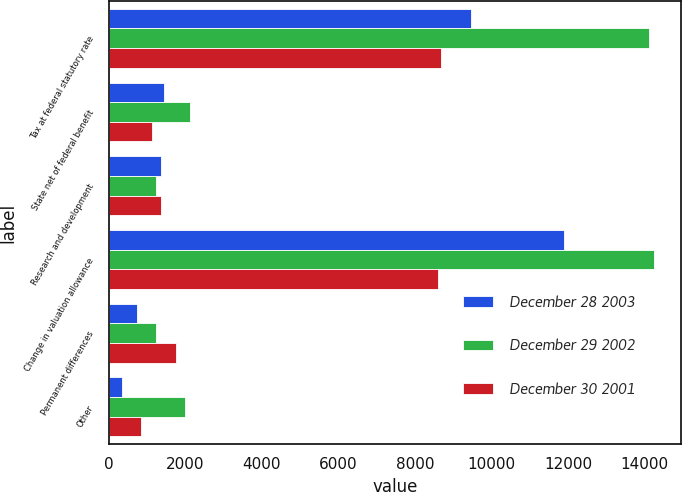Convert chart. <chart><loc_0><loc_0><loc_500><loc_500><stacked_bar_chart><ecel><fcel>Tax at federal statutory rate<fcel>State net of federal benefit<fcel>Research and development<fcel>Change in valuation allowance<fcel>Permanent differences<fcel>Other<nl><fcel>December 28 2003<fcel>9472<fcel>1434<fcel>1374<fcel>11893<fcel>738<fcel>351<nl><fcel>December 29 2002<fcel>14116<fcel>2115<fcel>1239<fcel>14241<fcel>1234<fcel>1995<nl><fcel>December 30 2001<fcel>8688<fcel>1138<fcel>1368<fcel>8604<fcel>1757<fcel>833<nl></chart> 